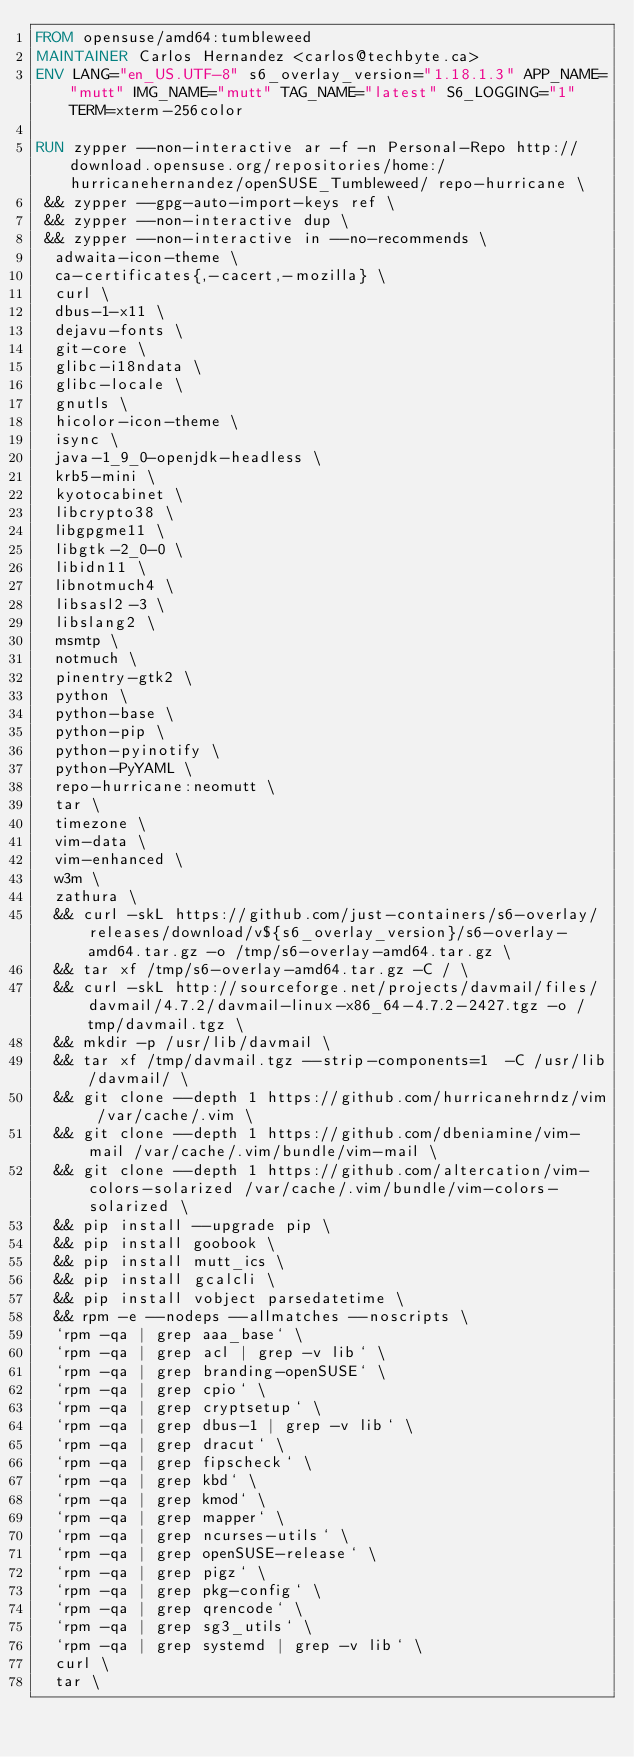Convert code to text. <code><loc_0><loc_0><loc_500><loc_500><_Dockerfile_>FROM opensuse/amd64:tumbleweed
MAINTAINER Carlos Hernandez <carlos@techbyte.ca>
ENV LANG="en_US.UTF-8" s6_overlay_version="1.18.1.3" APP_NAME="mutt" IMG_NAME="mutt" TAG_NAME="latest" S6_LOGGING="1" TERM=xterm-256color

RUN zypper --non-interactive ar -f -n Personal-Repo http://download.opensuse.org/repositories/home:/hurricanehernandez/openSUSE_Tumbleweed/ repo-hurricane \
 && zypper --gpg-auto-import-keys ref \
 && zypper --non-interactive dup \
 && zypper --non-interactive in --no-recommends \
	adwaita-icon-theme \
	ca-certificates{,-cacert,-mozilla} \
	curl \
	dbus-1-x11 \
	dejavu-fonts \
	git-core \
	glibc-i18ndata \
	glibc-locale \
	gnutls \
	hicolor-icon-theme \
	isync \
	java-1_9_0-openjdk-headless \
	krb5-mini \
	kyotocabinet \
	libcrypto38 \
	libgpgme11 \
	libgtk-2_0-0 \
	libidn11 \
	libnotmuch4 \
	libsasl2-3 \
	libslang2 \
	msmtp \
	notmuch \
	pinentry-gtk2 \
	python \
	python-base \
	python-pip \
	python-pyinotify \
	python-PyYAML \
	repo-hurricane:neomutt \
	tar \
	timezone \
	vim-data \
	vim-enhanced \
	w3m \
	zathura \
  && curl -skL https://github.com/just-containers/s6-overlay/releases/download/v${s6_overlay_version}/s6-overlay-amd64.tar.gz -o /tmp/s6-overlay-amd64.tar.gz \
  && tar xf /tmp/s6-overlay-amd64.tar.gz -C / \
  && curl -skL http://sourceforge.net/projects/davmail/files/davmail/4.7.2/davmail-linux-x86_64-4.7.2-2427.tgz -o /tmp/davmail.tgz \
  && mkdir -p /usr/lib/davmail \
  && tar xf /tmp/davmail.tgz --strip-components=1  -C /usr/lib/davmail/ \
  && git clone --depth 1 https://github.com/hurricanehrndz/vim /var/cache/.vim \
  && git clone --depth 1 https://github.com/dbeniamine/vim-mail /var/cache/.vim/bundle/vim-mail \
  && git clone --depth 1 https://github.com/altercation/vim-colors-solarized /var/cache/.vim/bundle/vim-colors-solarized \
  && pip install --upgrade pip \
  && pip install goobook \
  && pip install mutt_ics \
  && pip install gcalcli \
  && pip install vobject parsedatetime \
  && rpm -e --nodeps --allmatches --noscripts \
	`rpm -qa | grep aaa_base` \
	`rpm -qa | grep acl | grep -v lib` \
	`rpm -qa | grep branding-openSUSE` \
	`rpm -qa | grep cpio` \
	`rpm -qa | grep cryptsetup` \
	`rpm -qa | grep dbus-1 | grep -v lib` \
	`rpm -qa | grep dracut` \
	`rpm -qa | grep fipscheck` \
	`rpm -qa | grep kbd` \
	`rpm -qa | grep kmod` \
	`rpm -qa | grep mapper` \
	`rpm -qa | grep ncurses-utils` \
	`rpm -qa | grep openSUSE-release` \
	`rpm -qa | grep pigz` \
	`rpm -qa | grep pkg-config` \
	`rpm -qa | grep qrencode` \
	`rpm -qa | grep sg3_utils` \
	`rpm -qa | grep systemd | grep -v lib` \
	curl \
	tar \</code> 